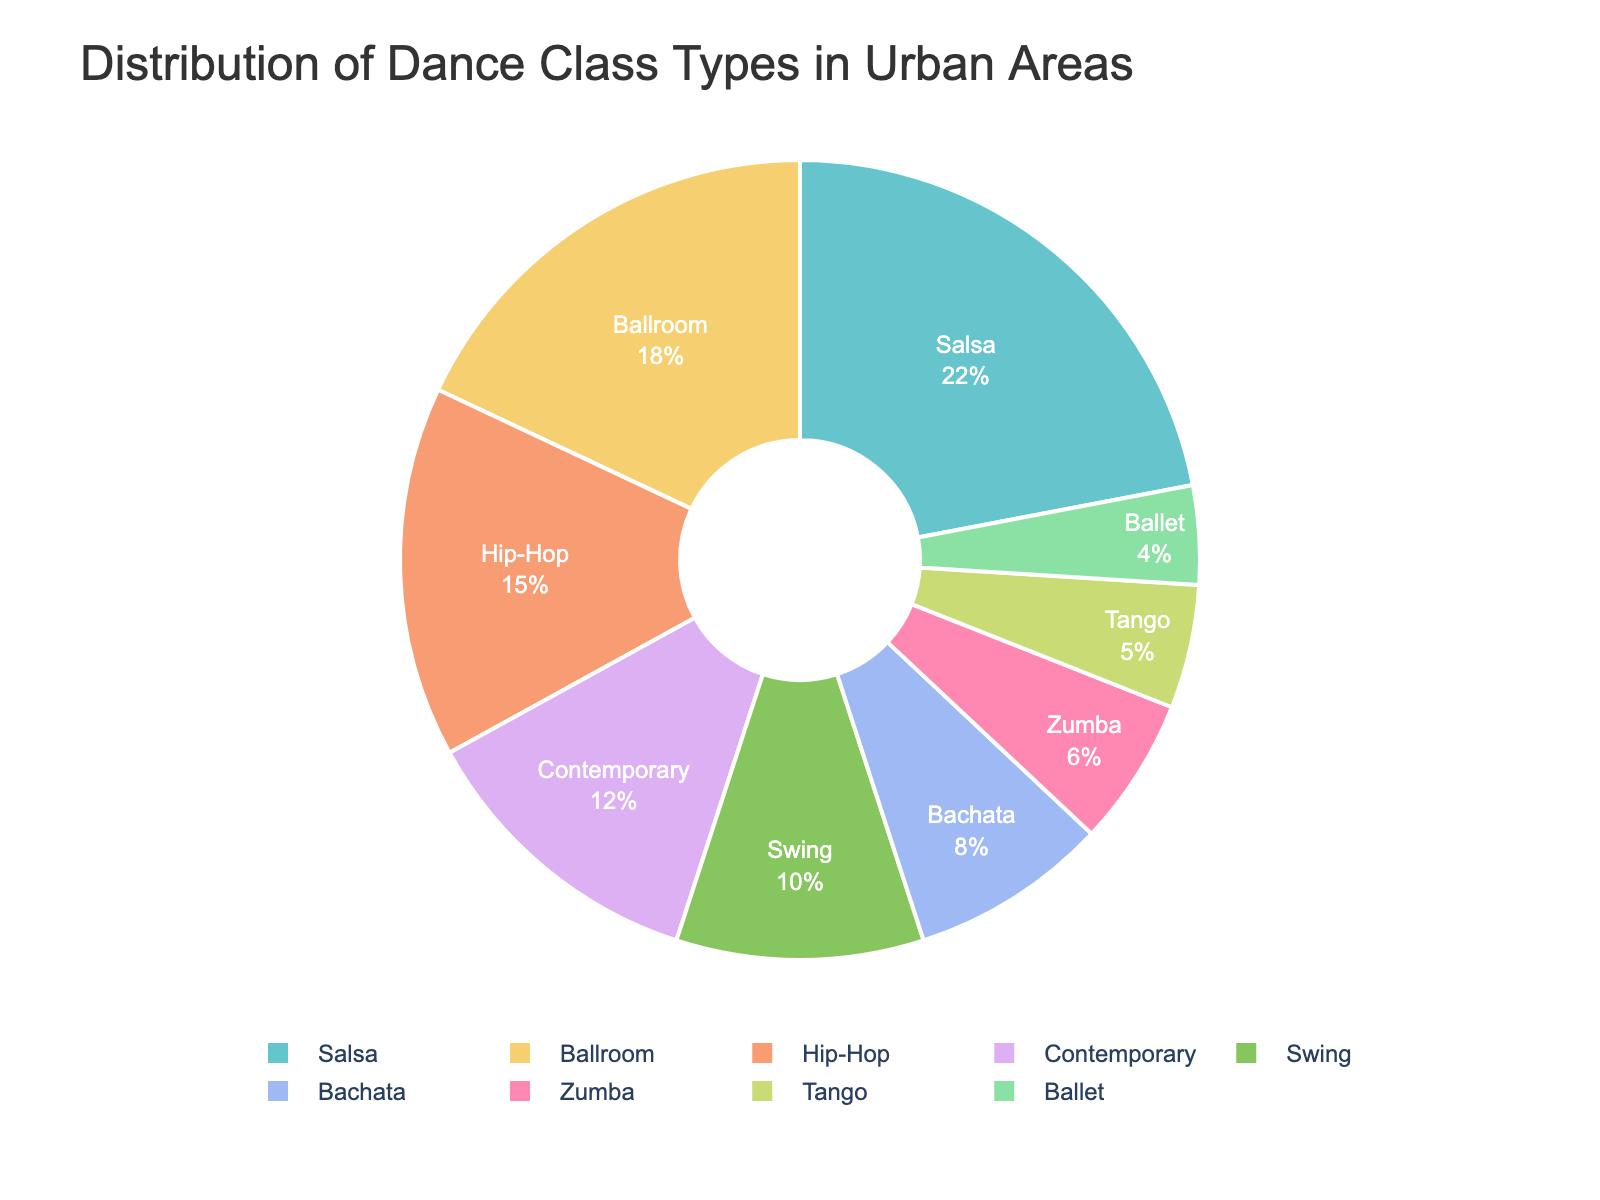What is the most popular dance class type in urban areas? Refer to the largest section of the pie chart, which represents the dance type with the highest percentage. The largest section is labeled "Salsa" with a percentage of 22%.
Answer: Salsa Which dance class type is more popular, Contemporary or Swing? Identify the sections of the pie chart that correspond to Contemporary and Swing. Compare their percentages; Contemporary is 12% and Swing is 10%. Since 12% > 10%, Contemporary is more popular.
Answer: Contemporary What is the combined percentage of Hip-Hop and Ballroom dance classes? Refer to the sections of the pie chart labeled Hip-Hop and Ballroom and add their percentages. Hip-Hop is 15% and Ballroom is 18%, so the sum is 15% + 18% = 33%.
Answer: 33% Which dance class types have less than 10% representation? Identify the sections of the pie chart that are less than 10%. In this case, Swing (10%), Bachata (8%), Zumba (6%), Tango (5%), and Ballet (4%) have less than 10% representation.
Answer: Bachata, Zumba, Tango, Ballet How much more popular is Salsa compared to Ballet? Refer to the percentages of Salsa and Ballet from the pie chart. Salsa is 22% and Ballet is 4%. Subtract the smaller percentage from the larger one: 22% - 4% = 18%.
Answer: 18% What percentage of dance classes are dedicated to Tango and Zumba combined? Refer to the sections of the pie chart labeled Tango and Zumba and add their percentages. Tango is 5% and Zumba is 6%, so the sum is 5% + 6% = 11%.
Answer: 11% Which dance class type is the least popular? Identify the smallest section of the pie chart. The smallest section is labeled Ballet with a percentage of 4%.
Answer: Ballet Are there more Ballroom or Salsa dance classes offered in urban areas? Identify the sections of the pie chart representing Ballroom and Salsa and compare their percentages. Salsa is 22% and Ballroom is 18%. Since 22% > 18%, there are more Salsa dance classes.
Answer: Salsa 